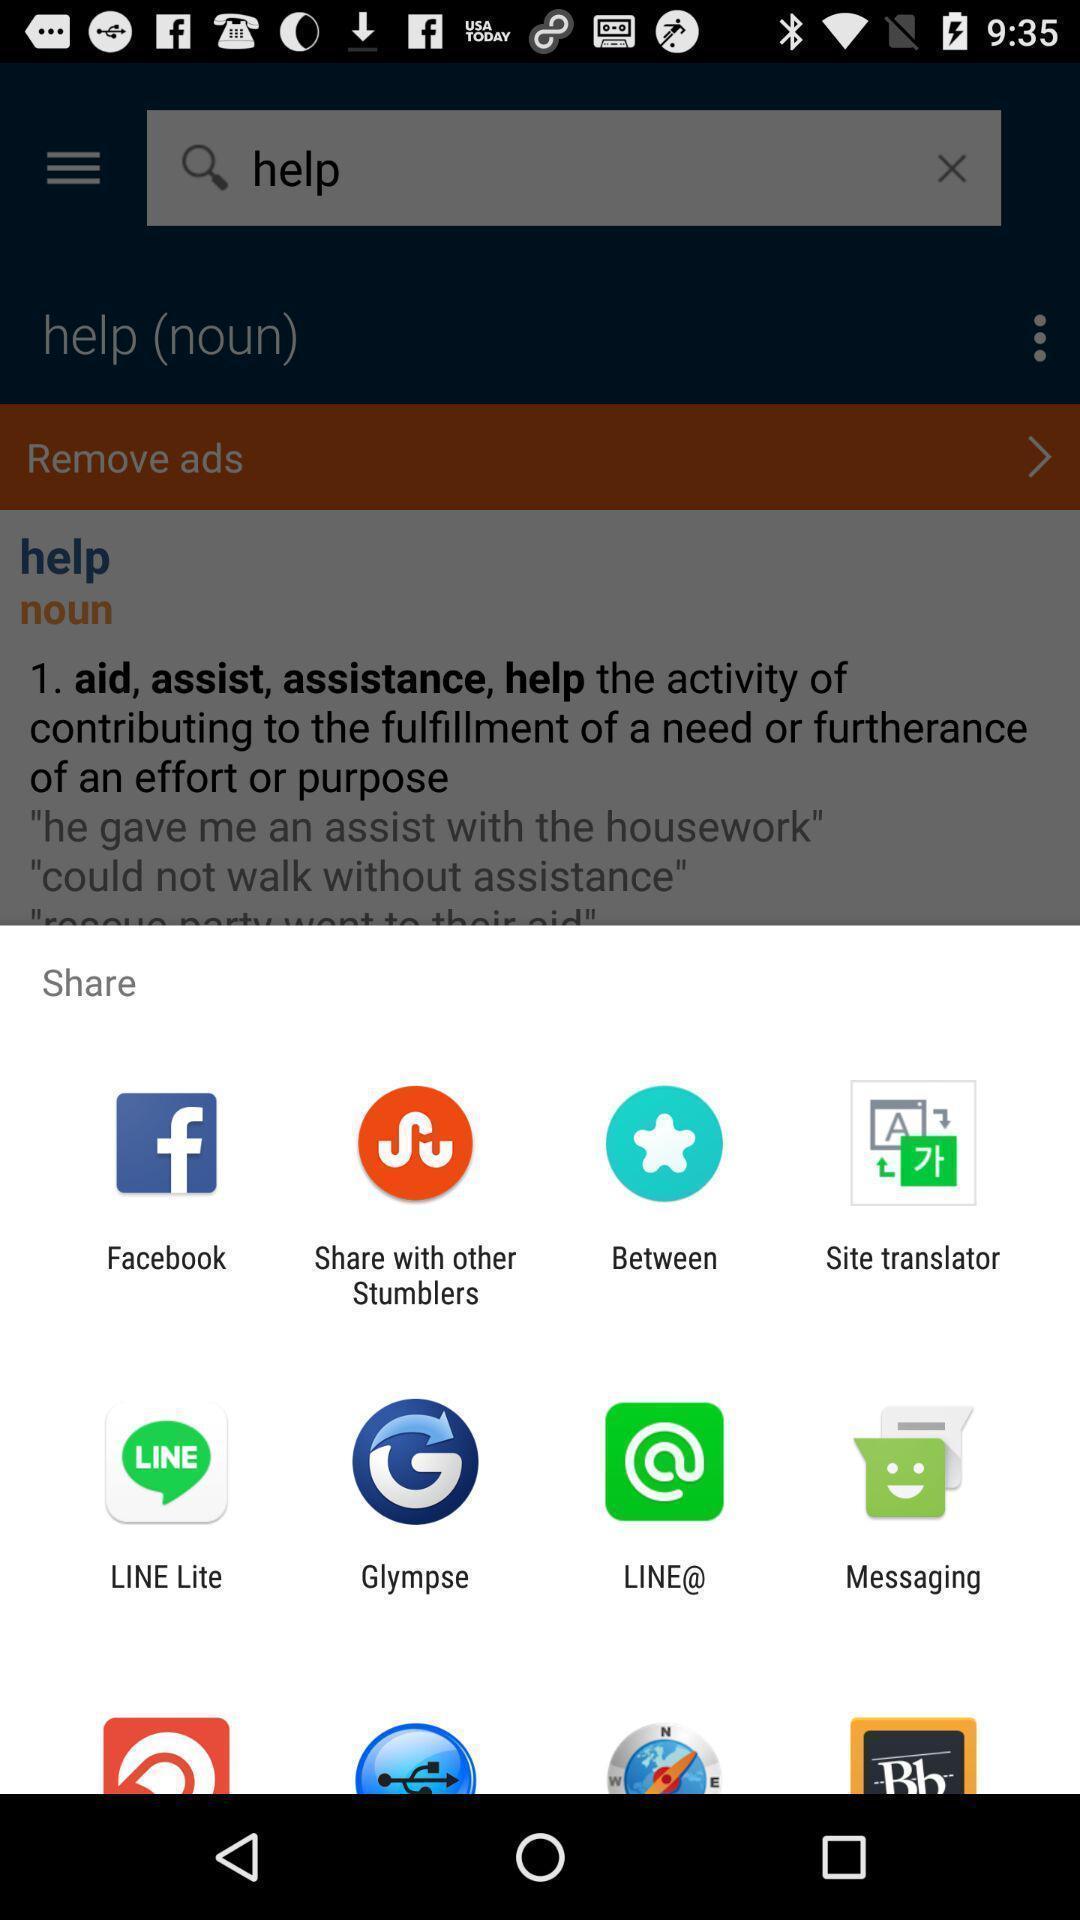Provide a detailed account of this screenshot. Pop-up showing for different sharing options. 